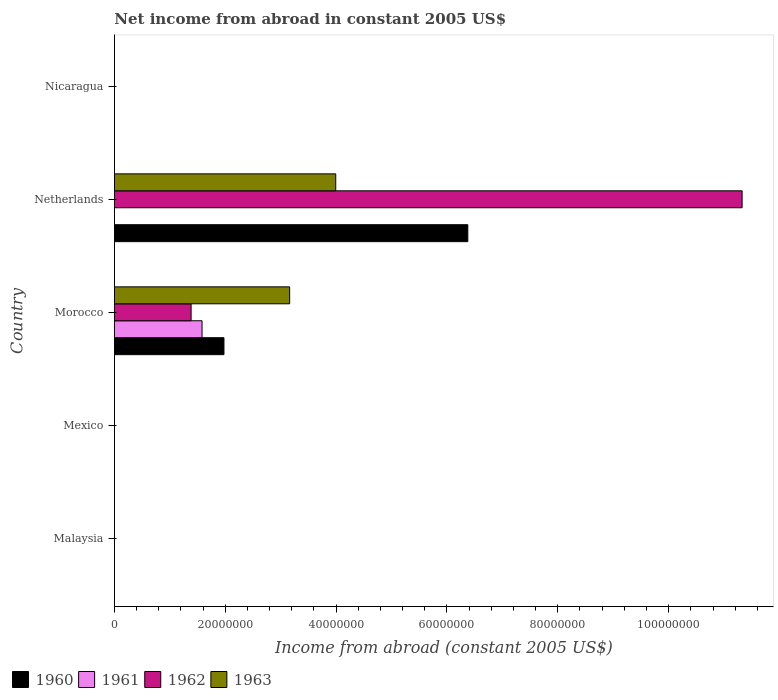How many bars are there on the 3rd tick from the bottom?
Offer a very short reply. 4. In how many cases, is the number of bars for a given country not equal to the number of legend labels?
Offer a very short reply. 4. What is the net income from abroad in 1960 in Morocco?
Give a very brief answer. 1.98e+07. Across all countries, what is the maximum net income from abroad in 1960?
Provide a succinct answer. 6.38e+07. Across all countries, what is the minimum net income from abroad in 1961?
Offer a terse response. 0. What is the total net income from abroad in 1960 in the graph?
Keep it short and to the point. 8.35e+07. What is the average net income from abroad in 1960 per country?
Your answer should be compact. 1.67e+07. What is the difference between the net income from abroad in 1962 and net income from abroad in 1960 in Netherlands?
Your answer should be very brief. 4.95e+07. In how many countries, is the net income from abroad in 1960 greater than 84000000 US$?
Ensure brevity in your answer.  0. What is the difference between the highest and the lowest net income from abroad in 1962?
Keep it short and to the point. 1.13e+08. Is it the case that in every country, the sum of the net income from abroad in 1963 and net income from abroad in 1962 is greater than the sum of net income from abroad in 1961 and net income from abroad in 1960?
Offer a very short reply. No. Is it the case that in every country, the sum of the net income from abroad in 1962 and net income from abroad in 1960 is greater than the net income from abroad in 1961?
Your answer should be very brief. No. Are all the bars in the graph horizontal?
Your answer should be very brief. Yes. How many countries are there in the graph?
Your answer should be compact. 5. What is the difference between two consecutive major ticks on the X-axis?
Your answer should be very brief. 2.00e+07. Does the graph contain any zero values?
Keep it short and to the point. Yes. Does the graph contain grids?
Your answer should be very brief. No. Where does the legend appear in the graph?
Your response must be concise. Bottom left. How are the legend labels stacked?
Your response must be concise. Horizontal. What is the title of the graph?
Keep it short and to the point. Net income from abroad in constant 2005 US$. What is the label or title of the X-axis?
Your response must be concise. Income from abroad (constant 2005 US$). What is the label or title of the Y-axis?
Ensure brevity in your answer.  Country. What is the Income from abroad (constant 2005 US$) of 1960 in Malaysia?
Give a very brief answer. 0. What is the Income from abroad (constant 2005 US$) of 1963 in Malaysia?
Ensure brevity in your answer.  0. What is the Income from abroad (constant 2005 US$) in 1960 in Mexico?
Offer a very short reply. 0. What is the Income from abroad (constant 2005 US$) in 1960 in Morocco?
Give a very brief answer. 1.98e+07. What is the Income from abroad (constant 2005 US$) of 1961 in Morocco?
Provide a short and direct response. 1.58e+07. What is the Income from abroad (constant 2005 US$) of 1962 in Morocco?
Ensure brevity in your answer.  1.38e+07. What is the Income from abroad (constant 2005 US$) in 1963 in Morocco?
Give a very brief answer. 3.16e+07. What is the Income from abroad (constant 2005 US$) of 1960 in Netherlands?
Your answer should be very brief. 6.38e+07. What is the Income from abroad (constant 2005 US$) of 1961 in Netherlands?
Provide a succinct answer. 0. What is the Income from abroad (constant 2005 US$) of 1962 in Netherlands?
Your answer should be compact. 1.13e+08. What is the Income from abroad (constant 2005 US$) in 1963 in Netherlands?
Keep it short and to the point. 3.99e+07. What is the Income from abroad (constant 2005 US$) of 1961 in Nicaragua?
Give a very brief answer. 0. What is the Income from abroad (constant 2005 US$) of 1963 in Nicaragua?
Keep it short and to the point. 0. Across all countries, what is the maximum Income from abroad (constant 2005 US$) in 1960?
Ensure brevity in your answer.  6.38e+07. Across all countries, what is the maximum Income from abroad (constant 2005 US$) in 1961?
Provide a short and direct response. 1.58e+07. Across all countries, what is the maximum Income from abroad (constant 2005 US$) in 1962?
Provide a succinct answer. 1.13e+08. Across all countries, what is the maximum Income from abroad (constant 2005 US$) of 1963?
Make the answer very short. 3.99e+07. Across all countries, what is the minimum Income from abroad (constant 2005 US$) in 1962?
Offer a very short reply. 0. What is the total Income from abroad (constant 2005 US$) in 1960 in the graph?
Your answer should be compact. 8.35e+07. What is the total Income from abroad (constant 2005 US$) in 1961 in the graph?
Give a very brief answer. 1.58e+07. What is the total Income from abroad (constant 2005 US$) in 1962 in the graph?
Give a very brief answer. 1.27e+08. What is the total Income from abroad (constant 2005 US$) in 1963 in the graph?
Make the answer very short. 7.15e+07. What is the difference between the Income from abroad (constant 2005 US$) in 1960 in Morocco and that in Netherlands?
Provide a short and direct response. -4.40e+07. What is the difference between the Income from abroad (constant 2005 US$) of 1962 in Morocco and that in Netherlands?
Make the answer very short. -9.94e+07. What is the difference between the Income from abroad (constant 2005 US$) in 1963 in Morocco and that in Netherlands?
Provide a short and direct response. -8.31e+06. What is the difference between the Income from abroad (constant 2005 US$) of 1960 in Morocco and the Income from abroad (constant 2005 US$) of 1962 in Netherlands?
Your answer should be very brief. -9.35e+07. What is the difference between the Income from abroad (constant 2005 US$) of 1960 in Morocco and the Income from abroad (constant 2005 US$) of 1963 in Netherlands?
Provide a succinct answer. -2.02e+07. What is the difference between the Income from abroad (constant 2005 US$) in 1961 in Morocco and the Income from abroad (constant 2005 US$) in 1962 in Netherlands?
Your answer should be very brief. -9.74e+07. What is the difference between the Income from abroad (constant 2005 US$) in 1961 in Morocco and the Income from abroad (constant 2005 US$) in 1963 in Netherlands?
Offer a terse response. -2.41e+07. What is the difference between the Income from abroad (constant 2005 US$) of 1962 in Morocco and the Income from abroad (constant 2005 US$) of 1963 in Netherlands?
Your response must be concise. -2.61e+07. What is the average Income from abroad (constant 2005 US$) in 1960 per country?
Make the answer very short. 1.67e+07. What is the average Income from abroad (constant 2005 US$) of 1961 per country?
Offer a terse response. 3.16e+06. What is the average Income from abroad (constant 2005 US$) of 1962 per country?
Offer a very short reply. 2.54e+07. What is the average Income from abroad (constant 2005 US$) in 1963 per country?
Give a very brief answer. 1.43e+07. What is the difference between the Income from abroad (constant 2005 US$) of 1960 and Income from abroad (constant 2005 US$) of 1961 in Morocco?
Your answer should be compact. 3.95e+06. What is the difference between the Income from abroad (constant 2005 US$) of 1960 and Income from abroad (constant 2005 US$) of 1962 in Morocco?
Give a very brief answer. 5.93e+06. What is the difference between the Income from abroad (constant 2005 US$) of 1960 and Income from abroad (constant 2005 US$) of 1963 in Morocco?
Make the answer very short. -1.19e+07. What is the difference between the Income from abroad (constant 2005 US$) in 1961 and Income from abroad (constant 2005 US$) in 1962 in Morocco?
Your answer should be very brief. 1.98e+06. What is the difference between the Income from abroad (constant 2005 US$) in 1961 and Income from abroad (constant 2005 US$) in 1963 in Morocco?
Offer a terse response. -1.58e+07. What is the difference between the Income from abroad (constant 2005 US$) in 1962 and Income from abroad (constant 2005 US$) in 1963 in Morocco?
Offer a very short reply. -1.78e+07. What is the difference between the Income from abroad (constant 2005 US$) in 1960 and Income from abroad (constant 2005 US$) in 1962 in Netherlands?
Your answer should be compact. -4.95e+07. What is the difference between the Income from abroad (constant 2005 US$) in 1960 and Income from abroad (constant 2005 US$) in 1963 in Netherlands?
Offer a terse response. 2.38e+07. What is the difference between the Income from abroad (constant 2005 US$) of 1962 and Income from abroad (constant 2005 US$) of 1963 in Netherlands?
Give a very brief answer. 7.33e+07. What is the ratio of the Income from abroad (constant 2005 US$) of 1960 in Morocco to that in Netherlands?
Offer a very short reply. 0.31. What is the ratio of the Income from abroad (constant 2005 US$) of 1962 in Morocco to that in Netherlands?
Your response must be concise. 0.12. What is the ratio of the Income from abroad (constant 2005 US$) of 1963 in Morocco to that in Netherlands?
Offer a very short reply. 0.79. What is the difference between the highest and the lowest Income from abroad (constant 2005 US$) in 1960?
Your response must be concise. 6.38e+07. What is the difference between the highest and the lowest Income from abroad (constant 2005 US$) in 1961?
Give a very brief answer. 1.58e+07. What is the difference between the highest and the lowest Income from abroad (constant 2005 US$) of 1962?
Your response must be concise. 1.13e+08. What is the difference between the highest and the lowest Income from abroad (constant 2005 US$) in 1963?
Offer a terse response. 3.99e+07. 